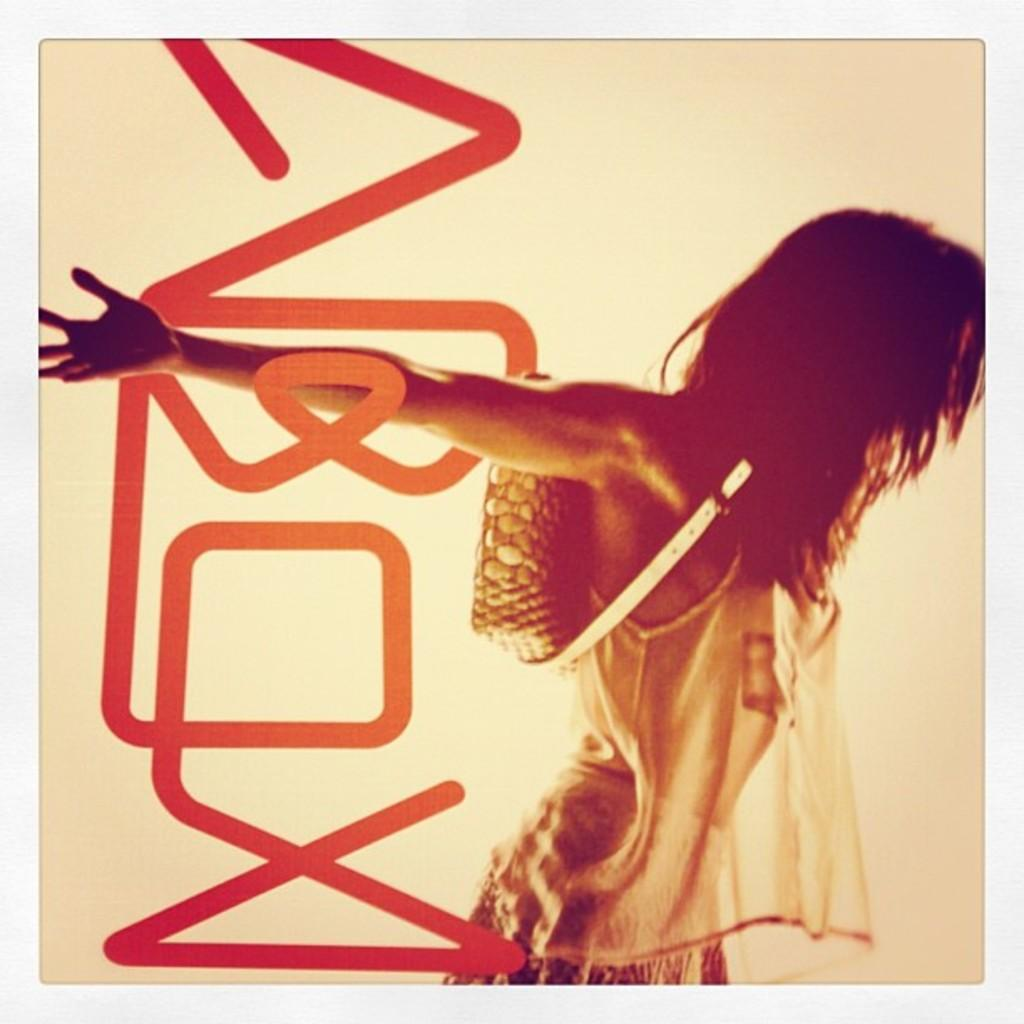Who or what is present on the right side of the image? There is a person on the right side of the image. What can be seen in the background of the image? The background of the image is white. What type of pie is being served to the person in the image? There is no pie present in the image; it only features a person on the right side with a white background. 